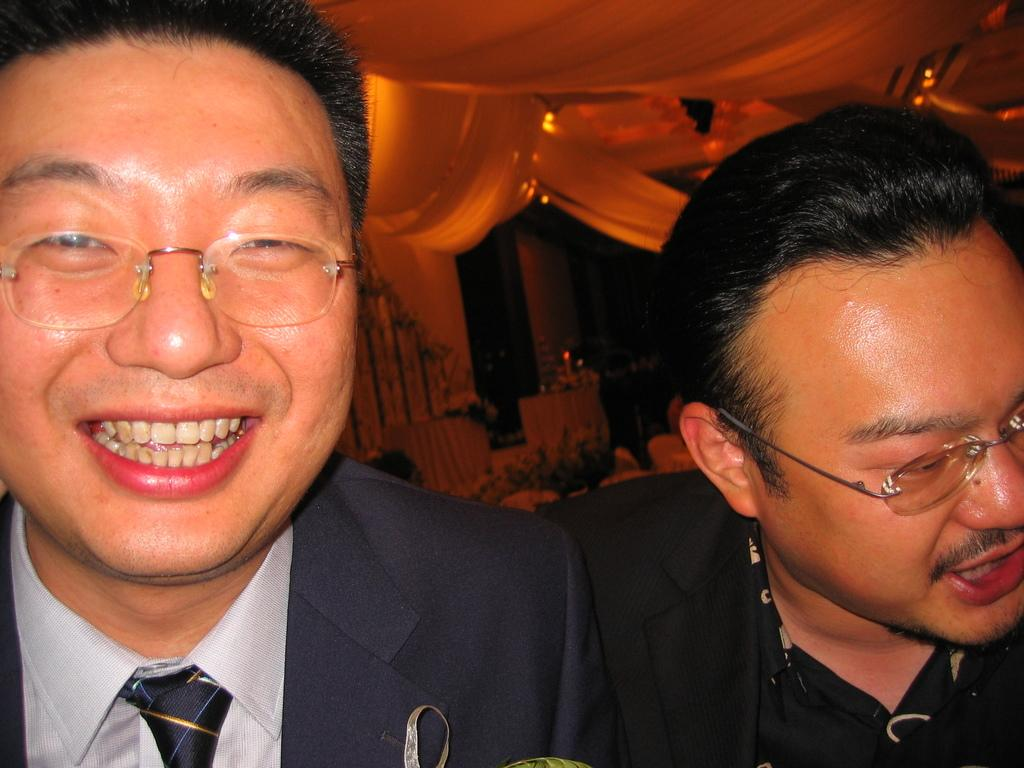How many people are present in the image? There are two persons in the image. Can you describe the objects in the background of the image? Unfortunately, the provided facts do not give any information about the objects in the background. What type of watch is the person wearing on their left foot in the image? There is no watch or mention of a watch in the image. Additionally, watches are typically worn on the wrist, not the foot. 